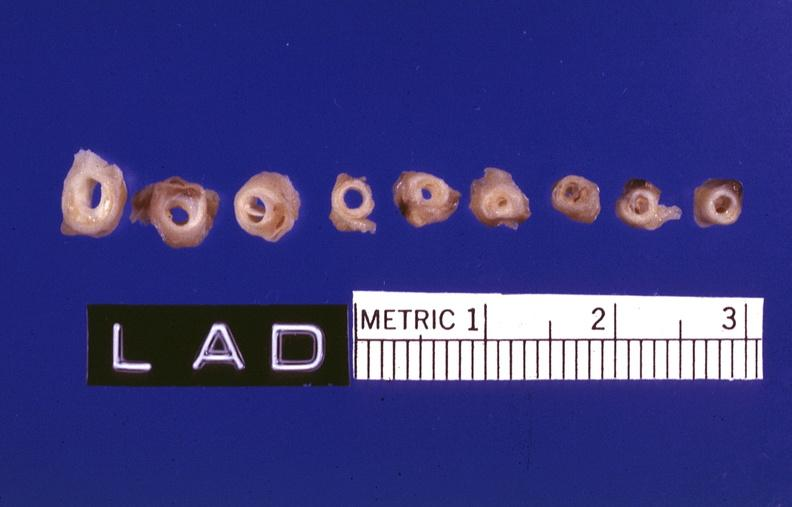what is present?
Answer the question using a single word or phrase. Cardiovascular 